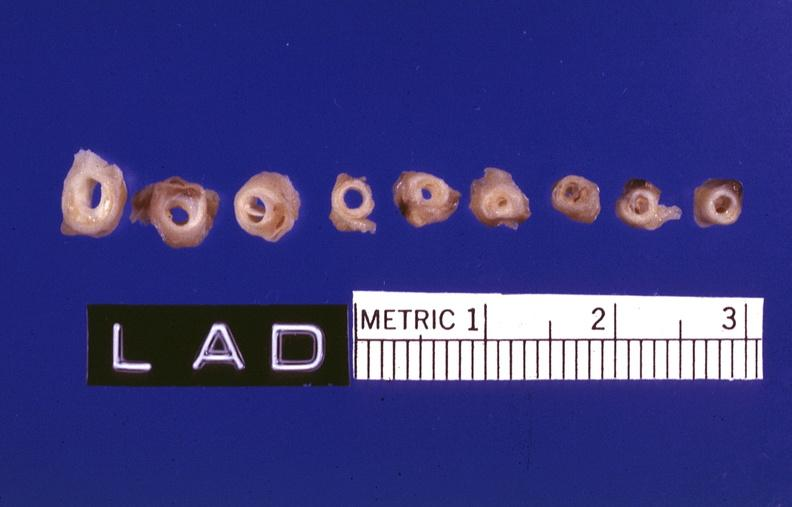what is present?
Answer the question using a single word or phrase. Cardiovascular 